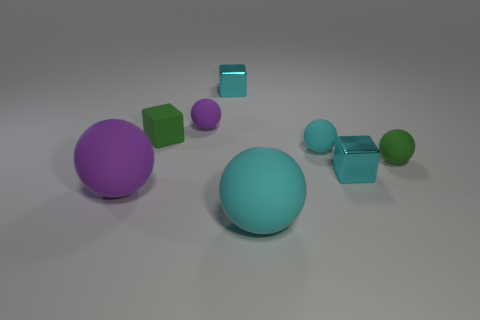Subtract all cyan balls. How many were subtracted if there are1cyan balls left? 1 Subtract all green spheres. How many spheres are left? 4 Add 2 big purple matte balls. How many objects exist? 10 Subtract all green blocks. How many blocks are left? 2 Subtract all spheres. How many objects are left? 3 Subtract 2 cubes. How many cubes are left? 1 Add 8 tiny cyan matte objects. How many tiny cyan matte objects exist? 9 Subtract 0 yellow spheres. How many objects are left? 8 Subtract all yellow cubes. Subtract all brown cylinders. How many cubes are left? 3 Subtract all blue cubes. How many gray balls are left? 0 